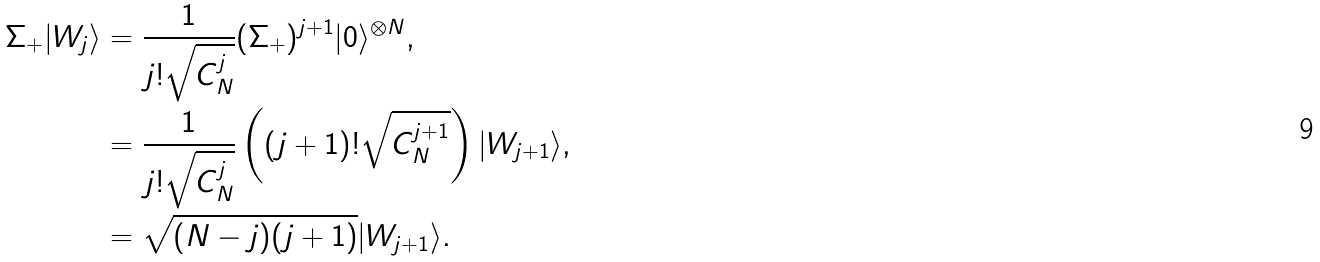Convert formula to latex. <formula><loc_0><loc_0><loc_500><loc_500>\Sigma _ { + } | W _ { j } \rangle & = \frac { 1 } { j ! \sqrt { C ^ { j } _ { N } } } ( \Sigma _ { + } ) ^ { j + 1 } | 0 \rangle ^ { \otimes N } , \\ & = \frac { 1 } { j ! \sqrt { C ^ { j } _ { N } } } \left ( ( j + 1 ) ! \sqrt { C ^ { j + 1 } _ { N } } \right ) | W _ { j + 1 } \rangle , \\ & = \sqrt { ( N - j ) ( j + 1 ) } | W _ { j + 1 } \rangle .</formula> 